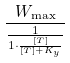<formula> <loc_0><loc_0><loc_500><loc_500>\frac { W _ { \max } } { \frac { 1 } { 1 \cdot \frac { [ T ] } { [ T ] + K _ { y } } } }</formula> 